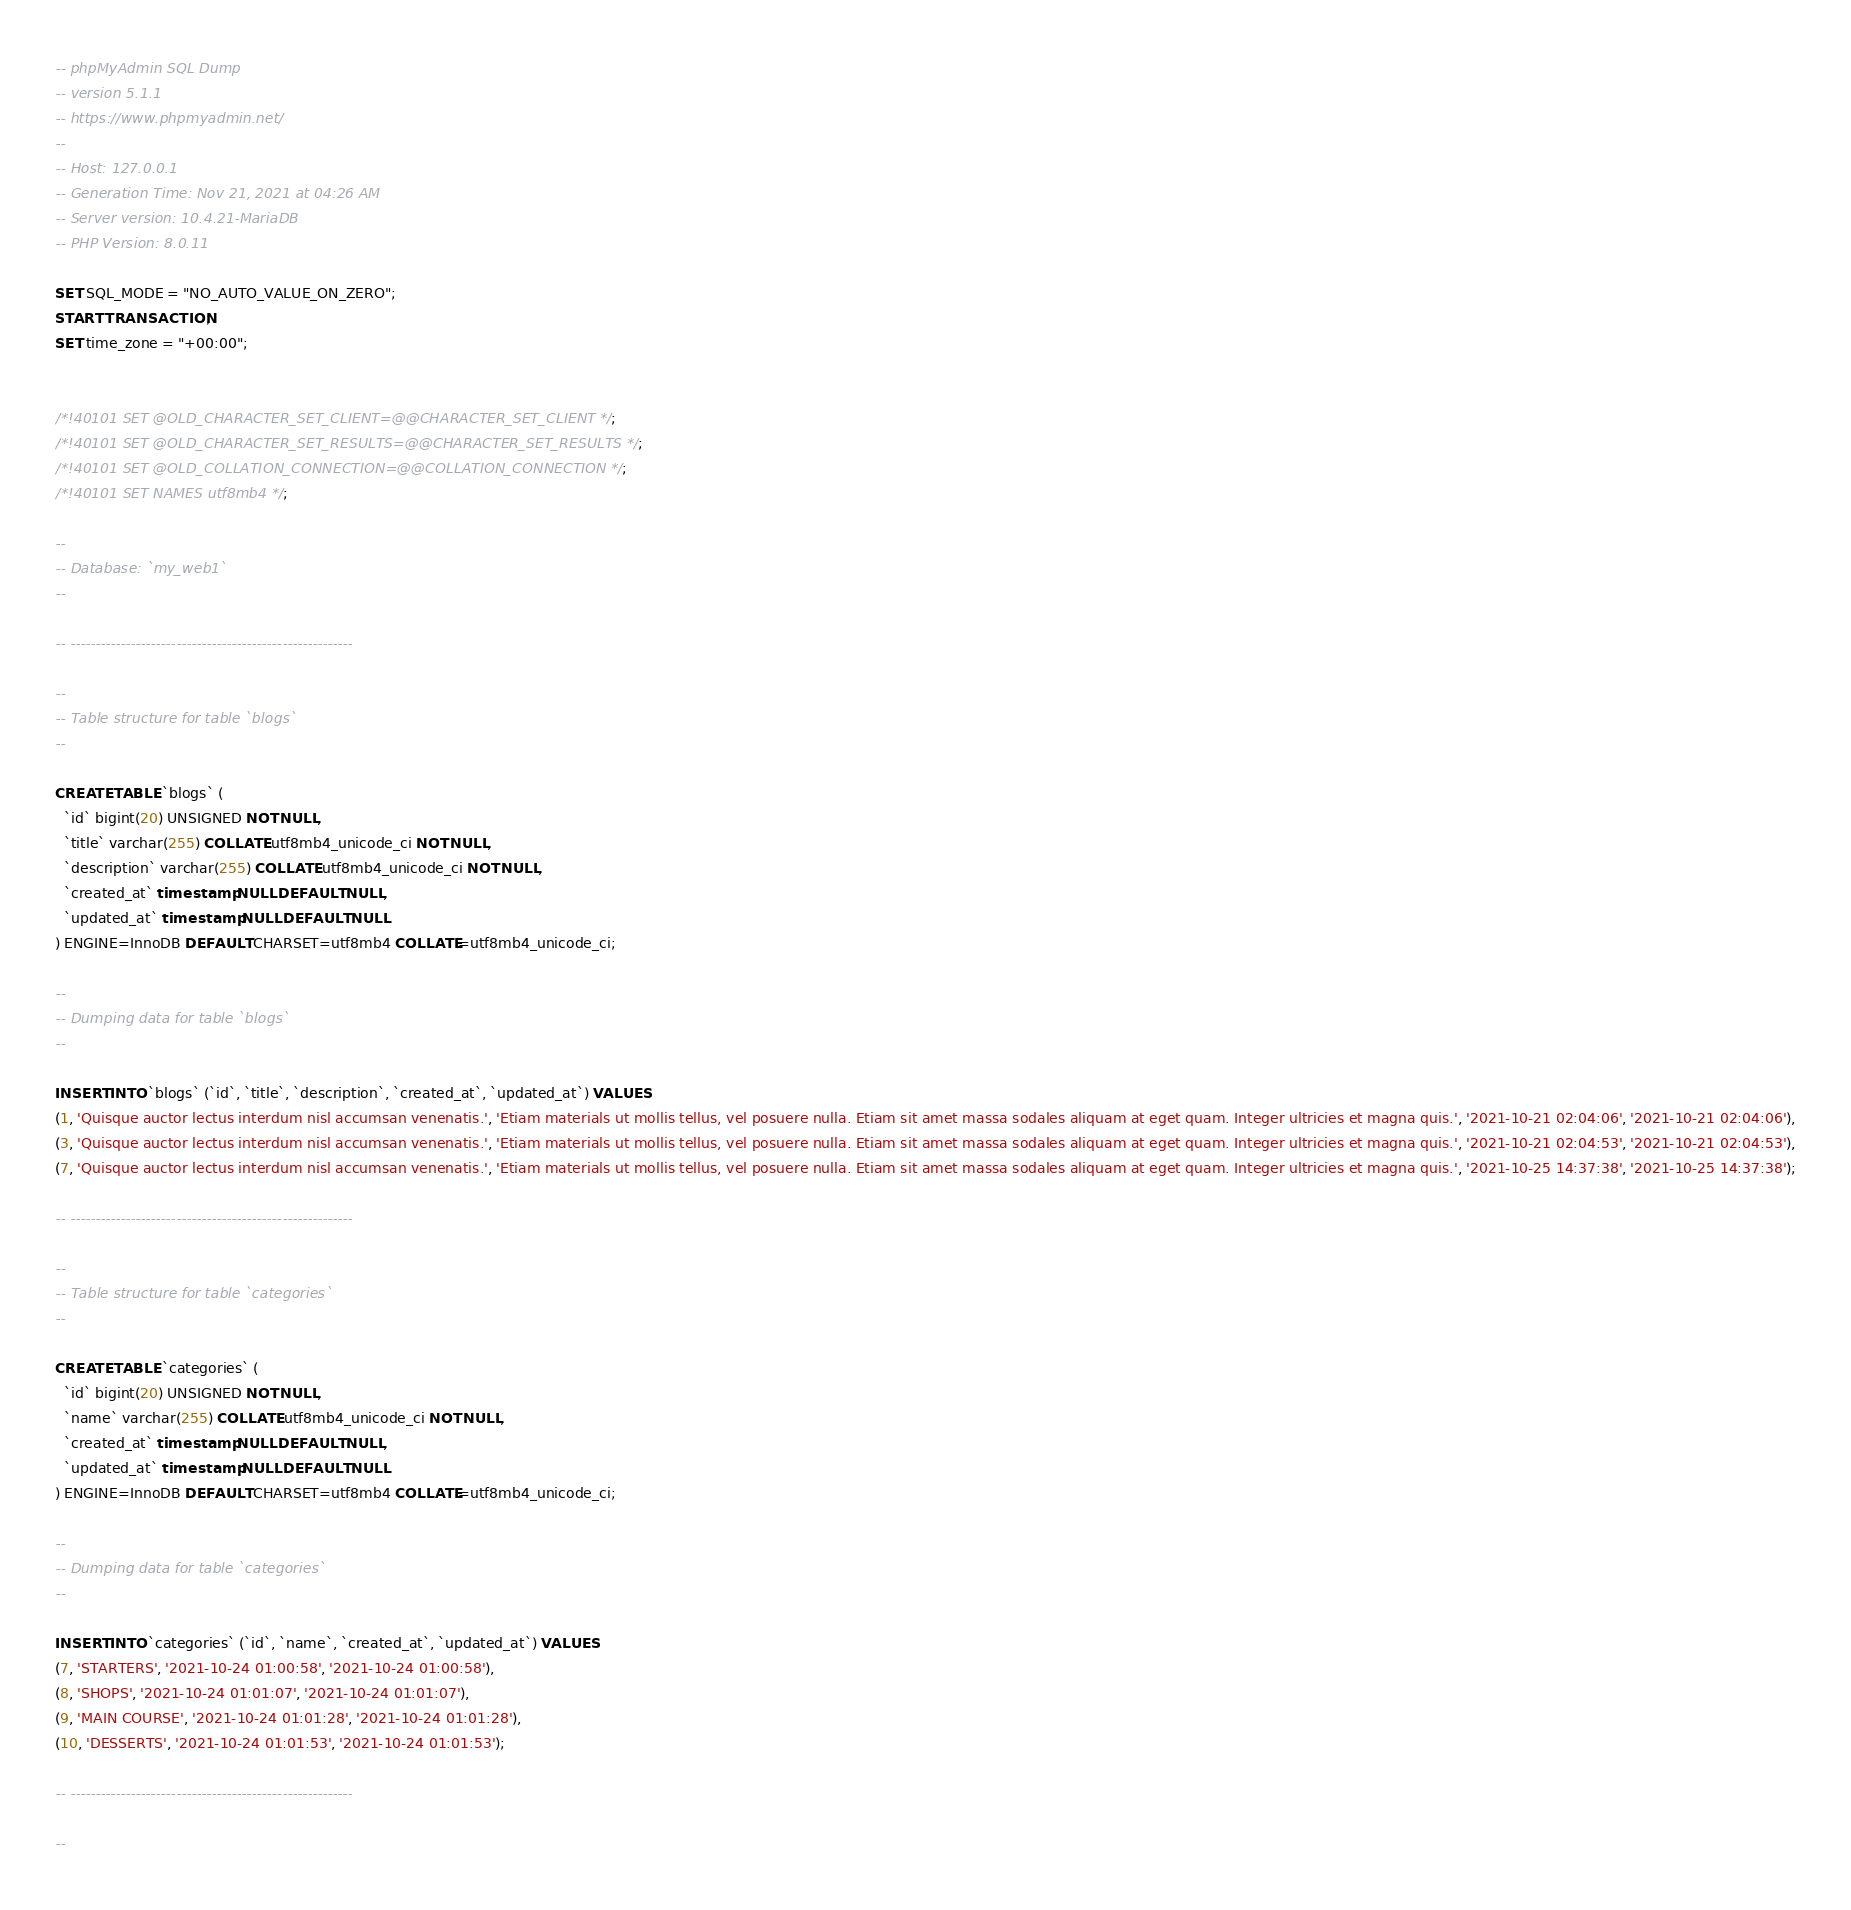Convert code to text. <code><loc_0><loc_0><loc_500><loc_500><_SQL_>-- phpMyAdmin SQL Dump
-- version 5.1.1
-- https://www.phpmyadmin.net/
--
-- Host: 127.0.0.1
-- Generation Time: Nov 21, 2021 at 04:26 AM
-- Server version: 10.4.21-MariaDB
-- PHP Version: 8.0.11

SET SQL_MODE = "NO_AUTO_VALUE_ON_ZERO";
START TRANSACTION;
SET time_zone = "+00:00";


/*!40101 SET @OLD_CHARACTER_SET_CLIENT=@@CHARACTER_SET_CLIENT */;
/*!40101 SET @OLD_CHARACTER_SET_RESULTS=@@CHARACTER_SET_RESULTS */;
/*!40101 SET @OLD_COLLATION_CONNECTION=@@COLLATION_CONNECTION */;
/*!40101 SET NAMES utf8mb4 */;

--
-- Database: `my_web1`
--

-- --------------------------------------------------------

--
-- Table structure for table `blogs`
--

CREATE TABLE `blogs` (
  `id` bigint(20) UNSIGNED NOT NULL,
  `title` varchar(255) COLLATE utf8mb4_unicode_ci NOT NULL,
  `description` varchar(255) COLLATE utf8mb4_unicode_ci NOT NULL,
  `created_at` timestamp NULL DEFAULT NULL,
  `updated_at` timestamp NULL DEFAULT NULL
) ENGINE=InnoDB DEFAULT CHARSET=utf8mb4 COLLATE=utf8mb4_unicode_ci;

--
-- Dumping data for table `blogs`
--

INSERT INTO `blogs` (`id`, `title`, `description`, `created_at`, `updated_at`) VALUES
(1, 'Quisque auctor lectus interdum nisl accumsan venenatis.', 'Etiam materials ut mollis tellus, vel posuere nulla. Etiam sit amet massa sodales aliquam at eget quam. Integer ultricies et magna quis.', '2021-10-21 02:04:06', '2021-10-21 02:04:06'),
(3, 'Quisque auctor lectus interdum nisl accumsan venenatis.', 'Etiam materials ut mollis tellus, vel posuere nulla. Etiam sit amet massa sodales aliquam at eget quam. Integer ultricies et magna quis.', '2021-10-21 02:04:53', '2021-10-21 02:04:53'),
(7, 'Quisque auctor lectus interdum nisl accumsan venenatis.', 'Etiam materials ut mollis tellus, vel posuere nulla. Etiam sit amet massa sodales aliquam at eget quam. Integer ultricies et magna quis.', '2021-10-25 14:37:38', '2021-10-25 14:37:38');

-- --------------------------------------------------------

--
-- Table structure for table `categories`
--

CREATE TABLE `categories` (
  `id` bigint(20) UNSIGNED NOT NULL,
  `name` varchar(255) COLLATE utf8mb4_unicode_ci NOT NULL,
  `created_at` timestamp NULL DEFAULT NULL,
  `updated_at` timestamp NULL DEFAULT NULL
) ENGINE=InnoDB DEFAULT CHARSET=utf8mb4 COLLATE=utf8mb4_unicode_ci;

--
-- Dumping data for table `categories`
--

INSERT INTO `categories` (`id`, `name`, `created_at`, `updated_at`) VALUES
(7, 'STARTERS', '2021-10-24 01:00:58', '2021-10-24 01:00:58'),
(8, 'SHOPS', '2021-10-24 01:01:07', '2021-10-24 01:01:07'),
(9, 'MAIN COURSE', '2021-10-24 01:01:28', '2021-10-24 01:01:28'),
(10, 'DESSERTS', '2021-10-24 01:01:53', '2021-10-24 01:01:53');

-- --------------------------------------------------------

--</code> 